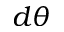<formula> <loc_0><loc_0><loc_500><loc_500>d \theta</formula> 